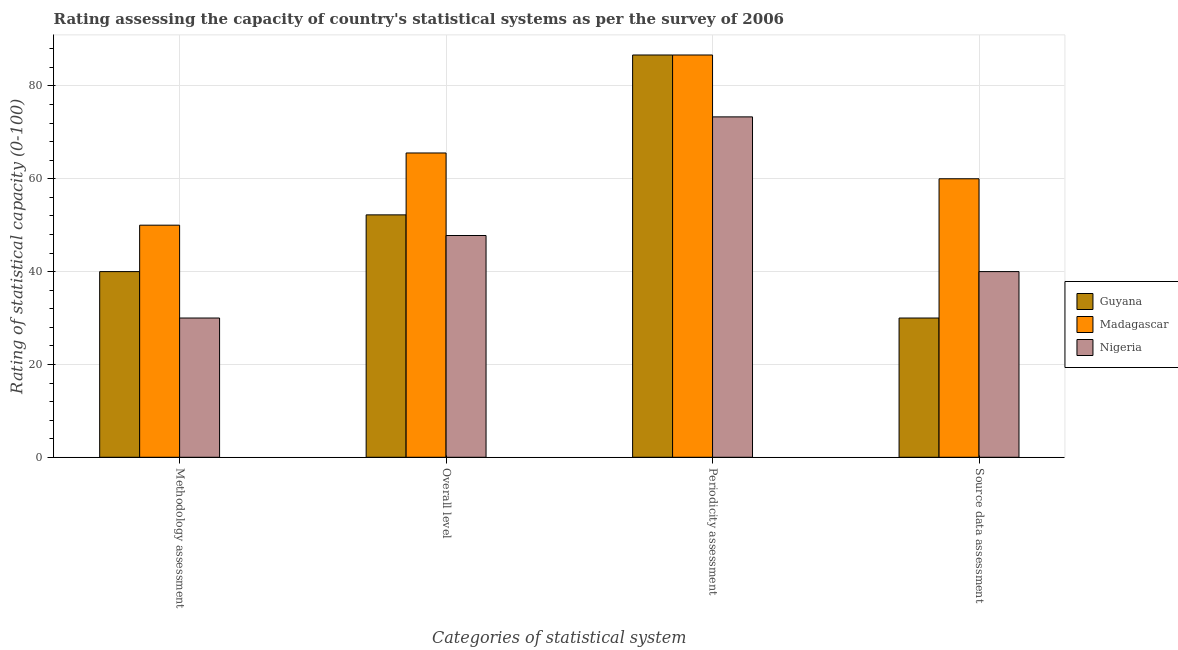How many groups of bars are there?
Your answer should be compact. 4. How many bars are there on the 4th tick from the left?
Your response must be concise. 3. What is the label of the 3rd group of bars from the left?
Offer a terse response. Periodicity assessment. What is the overall level rating in Guyana?
Your answer should be very brief. 52.22. Across all countries, what is the minimum periodicity assessment rating?
Make the answer very short. 73.33. In which country was the periodicity assessment rating maximum?
Make the answer very short. Guyana. In which country was the source data assessment rating minimum?
Give a very brief answer. Guyana. What is the total periodicity assessment rating in the graph?
Provide a short and direct response. 246.67. What is the difference between the periodicity assessment rating in Guyana and the overall level rating in Madagascar?
Give a very brief answer. 21.11. What is the average periodicity assessment rating per country?
Give a very brief answer. 82.22. What is the difference between the methodology assessment rating and periodicity assessment rating in Madagascar?
Make the answer very short. -36.67. In how many countries, is the periodicity assessment rating greater than 24 ?
Your answer should be compact. 3. What is the ratio of the overall level rating in Madagascar to that in Guyana?
Your answer should be compact. 1.26. Is the periodicity assessment rating in Nigeria less than that in Madagascar?
Provide a succinct answer. Yes. Is the difference between the periodicity assessment rating in Guyana and Nigeria greater than the difference between the source data assessment rating in Guyana and Nigeria?
Your answer should be very brief. Yes. What is the difference between the highest and the second highest periodicity assessment rating?
Offer a terse response. 0. What is the difference between the highest and the lowest overall level rating?
Ensure brevity in your answer.  17.78. In how many countries, is the overall level rating greater than the average overall level rating taken over all countries?
Ensure brevity in your answer.  1. What does the 3rd bar from the left in Source data assessment represents?
Give a very brief answer. Nigeria. What does the 3rd bar from the right in Source data assessment represents?
Provide a succinct answer. Guyana. Is it the case that in every country, the sum of the methodology assessment rating and overall level rating is greater than the periodicity assessment rating?
Make the answer very short. Yes. Are all the bars in the graph horizontal?
Give a very brief answer. No. Where does the legend appear in the graph?
Give a very brief answer. Center right. How are the legend labels stacked?
Offer a very short reply. Vertical. What is the title of the graph?
Offer a very short reply. Rating assessing the capacity of country's statistical systems as per the survey of 2006 . What is the label or title of the X-axis?
Offer a terse response. Categories of statistical system. What is the label or title of the Y-axis?
Provide a short and direct response. Rating of statistical capacity (0-100). What is the Rating of statistical capacity (0-100) in Nigeria in Methodology assessment?
Your response must be concise. 30. What is the Rating of statistical capacity (0-100) of Guyana in Overall level?
Your response must be concise. 52.22. What is the Rating of statistical capacity (0-100) in Madagascar in Overall level?
Ensure brevity in your answer.  65.56. What is the Rating of statistical capacity (0-100) of Nigeria in Overall level?
Provide a short and direct response. 47.78. What is the Rating of statistical capacity (0-100) in Guyana in Periodicity assessment?
Your answer should be very brief. 86.67. What is the Rating of statistical capacity (0-100) in Madagascar in Periodicity assessment?
Provide a short and direct response. 86.67. What is the Rating of statistical capacity (0-100) in Nigeria in Periodicity assessment?
Your answer should be very brief. 73.33. What is the Rating of statistical capacity (0-100) of Guyana in Source data assessment?
Your response must be concise. 30. What is the Rating of statistical capacity (0-100) in Nigeria in Source data assessment?
Provide a succinct answer. 40. Across all Categories of statistical system, what is the maximum Rating of statistical capacity (0-100) in Guyana?
Keep it short and to the point. 86.67. Across all Categories of statistical system, what is the maximum Rating of statistical capacity (0-100) of Madagascar?
Make the answer very short. 86.67. Across all Categories of statistical system, what is the maximum Rating of statistical capacity (0-100) in Nigeria?
Provide a short and direct response. 73.33. Across all Categories of statistical system, what is the minimum Rating of statistical capacity (0-100) of Guyana?
Provide a succinct answer. 30. Across all Categories of statistical system, what is the minimum Rating of statistical capacity (0-100) of Nigeria?
Your answer should be very brief. 30. What is the total Rating of statistical capacity (0-100) in Guyana in the graph?
Offer a terse response. 208.89. What is the total Rating of statistical capacity (0-100) of Madagascar in the graph?
Ensure brevity in your answer.  262.22. What is the total Rating of statistical capacity (0-100) of Nigeria in the graph?
Make the answer very short. 191.11. What is the difference between the Rating of statistical capacity (0-100) in Guyana in Methodology assessment and that in Overall level?
Give a very brief answer. -12.22. What is the difference between the Rating of statistical capacity (0-100) of Madagascar in Methodology assessment and that in Overall level?
Provide a succinct answer. -15.56. What is the difference between the Rating of statistical capacity (0-100) in Nigeria in Methodology assessment and that in Overall level?
Your answer should be compact. -17.78. What is the difference between the Rating of statistical capacity (0-100) in Guyana in Methodology assessment and that in Periodicity assessment?
Provide a succinct answer. -46.67. What is the difference between the Rating of statistical capacity (0-100) in Madagascar in Methodology assessment and that in Periodicity assessment?
Your answer should be compact. -36.67. What is the difference between the Rating of statistical capacity (0-100) in Nigeria in Methodology assessment and that in Periodicity assessment?
Provide a short and direct response. -43.33. What is the difference between the Rating of statistical capacity (0-100) of Madagascar in Methodology assessment and that in Source data assessment?
Give a very brief answer. -10. What is the difference between the Rating of statistical capacity (0-100) of Guyana in Overall level and that in Periodicity assessment?
Ensure brevity in your answer.  -34.44. What is the difference between the Rating of statistical capacity (0-100) of Madagascar in Overall level and that in Periodicity assessment?
Give a very brief answer. -21.11. What is the difference between the Rating of statistical capacity (0-100) in Nigeria in Overall level and that in Periodicity assessment?
Give a very brief answer. -25.56. What is the difference between the Rating of statistical capacity (0-100) in Guyana in Overall level and that in Source data assessment?
Keep it short and to the point. 22.22. What is the difference between the Rating of statistical capacity (0-100) in Madagascar in Overall level and that in Source data assessment?
Make the answer very short. 5.56. What is the difference between the Rating of statistical capacity (0-100) in Nigeria in Overall level and that in Source data assessment?
Provide a succinct answer. 7.78. What is the difference between the Rating of statistical capacity (0-100) in Guyana in Periodicity assessment and that in Source data assessment?
Offer a terse response. 56.67. What is the difference between the Rating of statistical capacity (0-100) in Madagascar in Periodicity assessment and that in Source data assessment?
Offer a terse response. 26.67. What is the difference between the Rating of statistical capacity (0-100) of Nigeria in Periodicity assessment and that in Source data assessment?
Offer a very short reply. 33.33. What is the difference between the Rating of statistical capacity (0-100) in Guyana in Methodology assessment and the Rating of statistical capacity (0-100) in Madagascar in Overall level?
Provide a short and direct response. -25.56. What is the difference between the Rating of statistical capacity (0-100) in Guyana in Methodology assessment and the Rating of statistical capacity (0-100) in Nigeria in Overall level?
Give a very brief answer. -7.78. What is the difference between the Rating of statistical capacity (0-100) in Madagascar in Methodology assessment and the Rating of statistical capacity (0-100) in Nigeria in Overall level?
Offer a terse response. 2.22. What is the difference between the Rating of statistical capacity (0-100) in Guyana in Methodology assessment and the Rating of statistical capacity (0-100) in Madagascar in Periodicity assessment?
Keep it short and to the point. -46.67. What is the difference between the Rating of statistical capacity (0-100) in Guyana in Methodology assessment and the Rating of statistical capacity (0-100) in Nigeria in Periodicity assessment?
Give a very brief answer. -33.33. What is the difference between the Rating of statistical capacity (0-100) in Madagascar in Methodology assessment and the Rating of statistical capacity (0-100) in Nigeria in Periodicity assessment?
Offer a terse response. -23.33. What is the difference between the Rating of statistical capacity (0-100) of Guyana in Methodology assessment and the Rating of statistical capacity (0-100) of Madagascar in Source data assessment?
Ensure brevity in your answer.  -20. What is the difference between the Rating of statistical capacity (0-100) of Guyana in Overall level and the Rating of statistical capacity (0-100) of Madagascar in Periodicity assessment?
Your response must be concise. -34.44. What is the difference between the Rating of statistical capacity (0-100) of Guyana in Overall level and the Rating of statistical capacity (0-100) of Nigeria in Periodicity assessment?
Your response must be concise. -21.11. What is the difference between the Rating of statistical capacity (0-100) of Madagascar in Overall level and the Rating of statistical capacity (0-100) of Nigeria in Periodicity assessment?
Make the answer very short. -7.78. What is the difference between the Rating of statistical capacity (0-100) of Guyana in Overall level and the Rating of statistical capacity (0-100) of Madagascar in Source data assessment?
Offer a very short reply. -7.78. What is the difference between the Rating of statistical capacity (0-100) of Guyana in Overall level and the Rating of statistical capacity (0-100) of Nigeria in Source data assessment?
Keep it short and to the point. 12.22. What is the difference between the Rating of statistical capacity (0-100) of Madagascar in Overall level and the Rating of statistical capacity (0-100) of Nigeria in Source data assessment?
Your answer should be compact. 25.56. What is the difference between the Rating of statistical capacity (0-100) in Guyana in Periodicity assessment and the Rating of statistical capacity (0-100) in Madagascar in Source data assessment?
Make the answer very short. 26.67. What is the difference between the Rating of statistical capacity (0-100) in Guyana in Periodicity assessment and the Rating of statistical capacity (0-100) in Nigeria in Source data assessment?
Offer a terse response. 46.67. What is the difference between the Rating of statistical capacity (0-100) of Madagascar in Periodicity assessment and the Rating of statistical capacity (0-100) of Nigeria in Source data assessment?
Give a very brief answer. 46.67. What is the average Rating of statistical capacity (0-100) of Guyana per Categories of statistical system?
Offer a very short reply. 52.22. What is the average Rating of statistical capacity (0-100) of Madagascar per Categories of statistical system?
Keep it short and to the point. 65.56. What is the average Rating of statistical capacity (0-100) of Nigeria per Categories of statistical system?
Provide a short and direct response. 47.78. What is the difference between the Rating of statistical capacity (0-100) in Guyana and Rating of statistical capacity (0-100) in Madagascar in Methodology assessment?
Offer a terse response. -10. What is the difference between the Rating of statistical capacity (0-100) in Guyana and Rating of statistical capacity (0-100) in Nigeria in Methodology assessment?
Make the answer very short. 10. What is the difference between the Rating of statistical capacity (0-100) of Madagascar and Rating of statistical capacity (0-100) of Nigeria in Methodology assessment?
Your answer should be very brief. 20. What is the difference between the Rating of statistical capacity (0-100) of Guyana and Rating of statistical capacity (0-100) of Madagascar in Overall level?
Make the answer very short. -13.33. What is the difference between the Rating of statistical capacity (0-100) of Guyana and Rating of statistical capacity (0-100) of Nigeria in Overall level?
Your response must be concise. 4.44. What is the difference between the Rating of statistical capacity (0-100) of Madagascar and Rating of statistical capacity (0-100) of Nigeria in Overall level?
Offer a terse response. 17.78. What is the difference between the Rating of statistical capacity (0-100) in Guyana and Rating of statistical capacity (0-100) in Madagascar in Periodicity assessment?
Your response must be concise. 0. What is the difference between the Rating of statistical capacity (0-100) of Guyana and Rating of statistical capacity (0-100) of Nigeria in Periodicity assessment?
Give a very brief answer. 13.33. What is the difference between the Rating of statistical capacity (0-100) of Madagascar and Rating of statistical capacity (0-100) of Nigeria in Periodicity assessment?
Your answer should be compact. 13.33. What is the difference between the Rating of statistical capacity (0-100) of Guyana and Rating of statistical capacity (0-100) of Nigeria in Source data assessment?
Keep it short and to the point. -10. What is the ratio of the Rating of statistical capacity (0-100) of Guyana in Methodology assessment to that in Overall level?
Ensure brevity in your answer.  0.77. What is the ratio of the Rating of statistical capacity (0-100) of Madagascar in Methodology assessment to that in Overall level?
Your answer should be compact. 0.76. What is the ratio of the Rating of statistical capacity (0-100) in Nigeria in Methodology assessment to that in Overall level?
Keep it short and to the point. 0.63. What is the ratio of the Rating of statistical capacity (0-100) of Guyana in Methodology assessment to that in Periodicity assessment?
Your answer should be compact. 0.46. What is the ratio of the Rating of statistical capacity (0-100) of Madagascar in Methodology assessment to that in Periodicity assessment?
Provide a short and direct response. 0.58. What is the ratio of the Rating of statistical capacity (0-100) of Nigeria in Methodology assessment to that in Periodicity assessment?
Your answer should be very brief. 0.41. What is the ratio of the Rating of statistical capacity (0-100) of Nigeria in Methodology assessment to that in Source data assessment?
Your answer should be compact. 0.75. What is the ratio of the Rating of statistical capacity (0-100) of Guyana in Overall level to that in Periodicity assessment?
Offer a terse response. 0.6. What is the ratio of the Rating of statistical capacity (0-100) of Madagascar in Overall level to that in Periodicity assessment?
Ensure brevity in your answer.  0.76. What is the ratio of the Rating of statistical capacity (0-100) in Nigeria in Overall level to that in Periodicity assessment?
Keep it short and to the point. 0.65. What is the ratio of the Rating of statistical capacity (0-100) of Guyana in Overall level to that in Source data assessment?
Your response must be concise. 1.74. What is the ratio of the Rating of statistical capacity (0-100) in Madagascar in Overall level to that in Source data assessment?
Your answer should be very brief. 1.09. What is the ratio of the Rating of statistical capacity (0-100) in Nigeria in Overall level to that in Source data assessment?
Make the answer very short. 1.19. What is the ratio of the Rating of statistical capacity (0-100) in Guyana in Periodicity assessment to that in Source data assessment?
Keep it short and to the point. 2.89. What is the ratio of the Rating of statistical capacity (0-100) in Madagascar in Periodicity assessment to that in Source data assessment?
Your answer should be very brief. 1.44. What is the ratio of the Rating of statistical capacity (0-100) in Nigeria in Periodicity assessment to that in Source data assessment?
Your response must be concise. 1.83. What is the difference between the highest and the second highest Rating of statistical capacity (0-100) of Guyana?
Ensure brevity in your answer.  34.44. What is the difference between the highest and the second highest Rating of statistical capacity (0-100) in Madagascar?
Keep it short and to the point. 21.11. What is the difference between the highest and the second highest Rating of statistical capacity (0-100) of Nigeria?
Ensure brevity in your answer.  25.56. What is the difference between the highest and the lowest Rating of statistical capacity (0-100) in Guyana?
Your answer should be very brief. 56.67. What is the difference between the highest and the lowest Rating of statistical capacity (0-100) in Madagascar?
Provide a short and direct response. 36.67. What is the difference between the highest and the lowest Rating of statistical capacity (0-100) of Nigeria?
Make the answer very short. 43.33. 